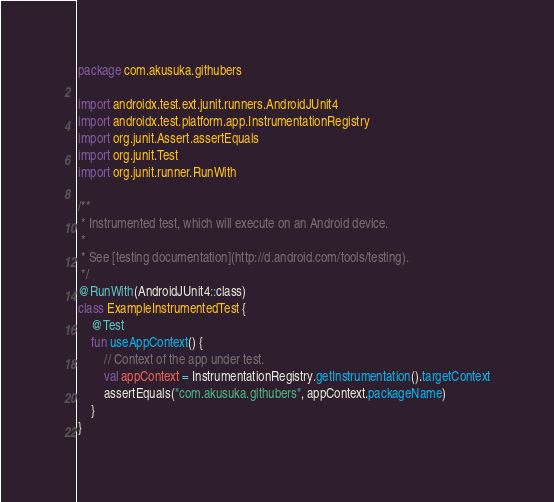<code> <loc_0><loc_0><loc_500><loc_500><_Kotlin_>package com.akusuka.githubers

import androidx.test.ext.junit.runners.AndroidJUnit4
import androidx.test.platform.app.InstrumentationRegistry
import org.junit.Assert.assertEquals
import org.junit.Test
import org.junit.runner.RunWith

/**
 * Instrumented test, which will execute on an Android device.
 *
 * See [testing documentation](http://d.android.com/tools/testing).
 */
@RunWith(AndroidJUnit4::class)
class ExampleInstrumentedTest {
    @Test
    fun useAppContext() {
        // Context of the app under test.
        val appContext = InstrumentationRegistry.getInstrumentation().targetContext
        assertEquals("com.akusuka.githubers", appContext.packageName)
    }
}</code> 